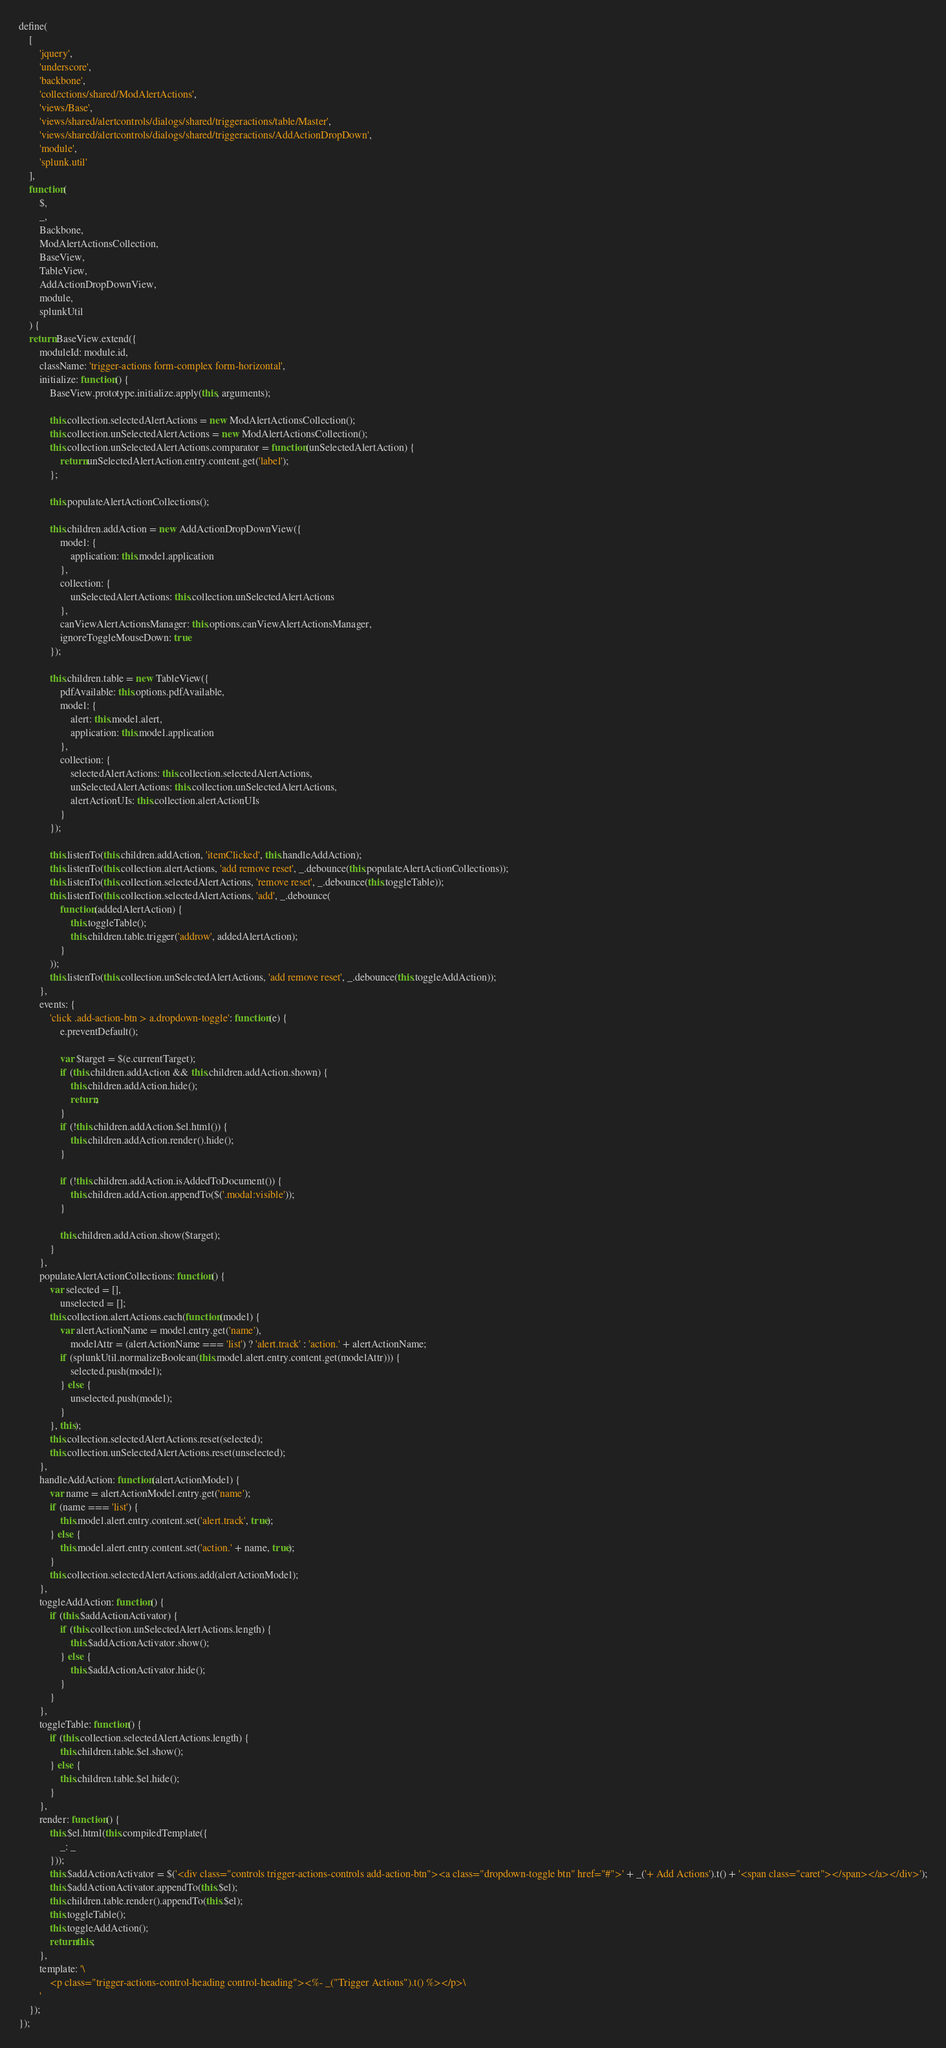<code> <loc_0><loc_0><loc_500><loc_500><_JavaScript_>define(
    [
        'jquery',
        'underscore',
        'backbone',
        'collections/shared/ModAlertActions',
        'views/Base',
        'views/shared/alertcontrols/dialogs/shared/triggeractions/table/Master',
        'views/shared/alertcontrols/dialogs/shared/triggeractions/AddActionDropDown',
        'module',
        'splunk.util'
    ],
    function(
        $,
        _,
        Backbone,
        ModAlertActionsCollection,
        BaseView,
        TableView,
        AddActionDropDownView,
        module,
        splunkUtil
    ) {
    return BaseView.extend({
        moduleId: module.id,
        className: 'trigger-actions form-complex form-horizontal',
        initialize: function() {
            BaseView.prototype.initialize.apply(this, arguments);

            this.collection.selectedAlertActions = new ModAlertActionsCollection();
            this.collection.unSelectedAlertActions = new ModAlertActionsCollection();
            this.collection.unSelectedAlertActions.comparator = function(unSelectedAlertAction) {
                return unSelectedAlertAction.entry.content.get('label');
            };

            this.populateAlertActionCollections();

            this.children.addAction = new AddActionDropDownView({
                model: {
                    application: this.model.application
                },
                collection: {
                    unSelectedAlertActions: this.collection.unSelectedAlertActions
                },
                canViewAlertActionsManager: this.options.canViewAlertActionsManager,
                ignoreToggleMouseDown: true
            });

            this.children.table = new TableView({
                pdfAvailable: this.options.pdfAvailable,
                model: {
                    alert: this.model.alert,
                    application: this.model.application
                },
                collection: {
                    selectedAlertActions: this.collection.selectedAlertActions,
                    unSelectedAlertActions: this.collection.unSelectedAlertActions,
                    alertActionUIs: this.collection.alertActionUIs
                }
            });

            this.listenTo(this.children.addAction, 'itemClicked', this.handleAddAction);
            this.listenTo(this.collection.alertActions, 'add remove reset', _.debounce(this.populateAlertActionCollections));
            this.listenTo(this.collection.selectedAlertActions, 'remove reset', _.debounce(this.toggleTable));
            this.listenTo(this.collection.selectedAlertActions, 'add', _.debounce(
                function(addedAlertAction) {
                    this.toggleTable();
                    this.children.table.trigger('addrow', addedAlertAction);
                }
            ));
            this.listenTo(this.collection.unSelectedAlertActions, 'add remove reset', _.debounce(this.toggleAddAction));
        },
        events: {
            'click .add-action-btn > a.dropdown-toggle': function(e) {
                e.preventDefault();

                var $target = $(e.currentTarget);
                if (this.children.addAction && this.children.addAction.shown) {
                    this.children.addAction.hide();
                    return;
                }
                if (!this.children.addAction.$el.html()) {
                    this.children.addAction.render().hide();
                }

                if (!this.children.addAction.isAddedToDocument()) {
                    this.children.addAction.appendTo($('.modal:visible'));
                }

                this.children.addAction.show($target);
            }
        },
        populateAlertActionCollections: function() {
            var selected = [],
                unselected = [];
            this.collection.alertActions.each(function(model) {
                var alertActionName = model.entry.get('name'),
                    modelAttr = (alertActionName === 'list') ? 'alert.track' : 'action.' + alertActionName;
                if (splunkUtil.normalizeBoolean(this.model.alert.entry.content.get(modelAttr))) {
                    selected.push(model);
                } else {
                    unselected.push(model);
                }
            }, this);
            this.collection.selectedAlertActions.reset(selected);
            this.collection.unSelectedAlertActions.reset(unselected);
        },
        handleAddAction: function(alertActionModel) {
            var name = alertActionModel.entry.get('name');
            if (name === 'list') {
                this.model.alert.entry.content.set('alert.track', true);
            } else {
                this.model.alert.entry.content.set('action.' + name, true);
            }
            this.collection.selectedAlertActions.add(alertActionModel);
        },
        toggleAddAction: function() {
            if (this.$addActionActivator) {
                if (this.collection.unSelectedAlertActions.length) {
                    this.$addActionActivator.show();
                } else {
                    this.$addActionActivator.hide();
                }
            }
        },
        toggleTable: function() {
            if (this.collection.selectedAlertActions.length) {
                this.children.table.$el.show();
            } else {
                this.children.table.$el.hide();
            }
        },
        render: function() {
            this.$el.html(this.compiledTemplate({
                _: _
            }));
            this.$addActionActivator = $('<div class="controls trigger-actions-controls add-action-btn"><a class="dropdown-toggle btn" href="#">' + _('+ Add Actions').t() + '<span class="caret"></span></a></div>');
            this.$addActionActivator.appendTo(this.$el);
            this.children.table.render().appendTo(this.$el);
            this.toggleTable();
            this.toggleAddAction();
            return this;
        },
        template: '\
            <p class="trigger-actions-control-heading control-heading"><%- _("Trigger Actions").t() %></p>\
        '
    });
});
</code> 